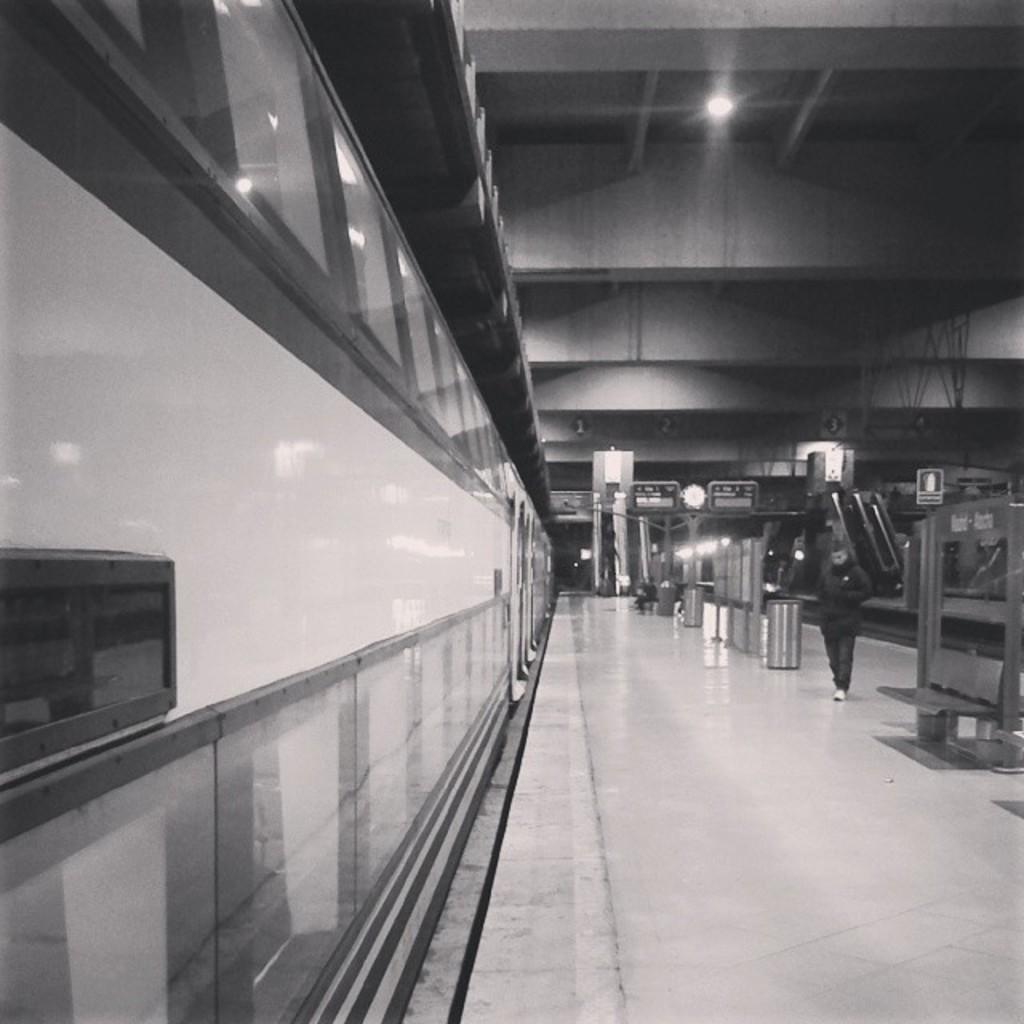Could you give a brief overview of what you see in this image? In this image we can see a railway station. We can see a train at the left side of the image. There is a railway track at the right side of the image. We can see the reflections of the lights on the train. There are few lights in the image. There are few boards in the image. We can see a person sitting on the bench. There are few benches in the image. We can see a person walking in the image. There are few dustbins in the image. 